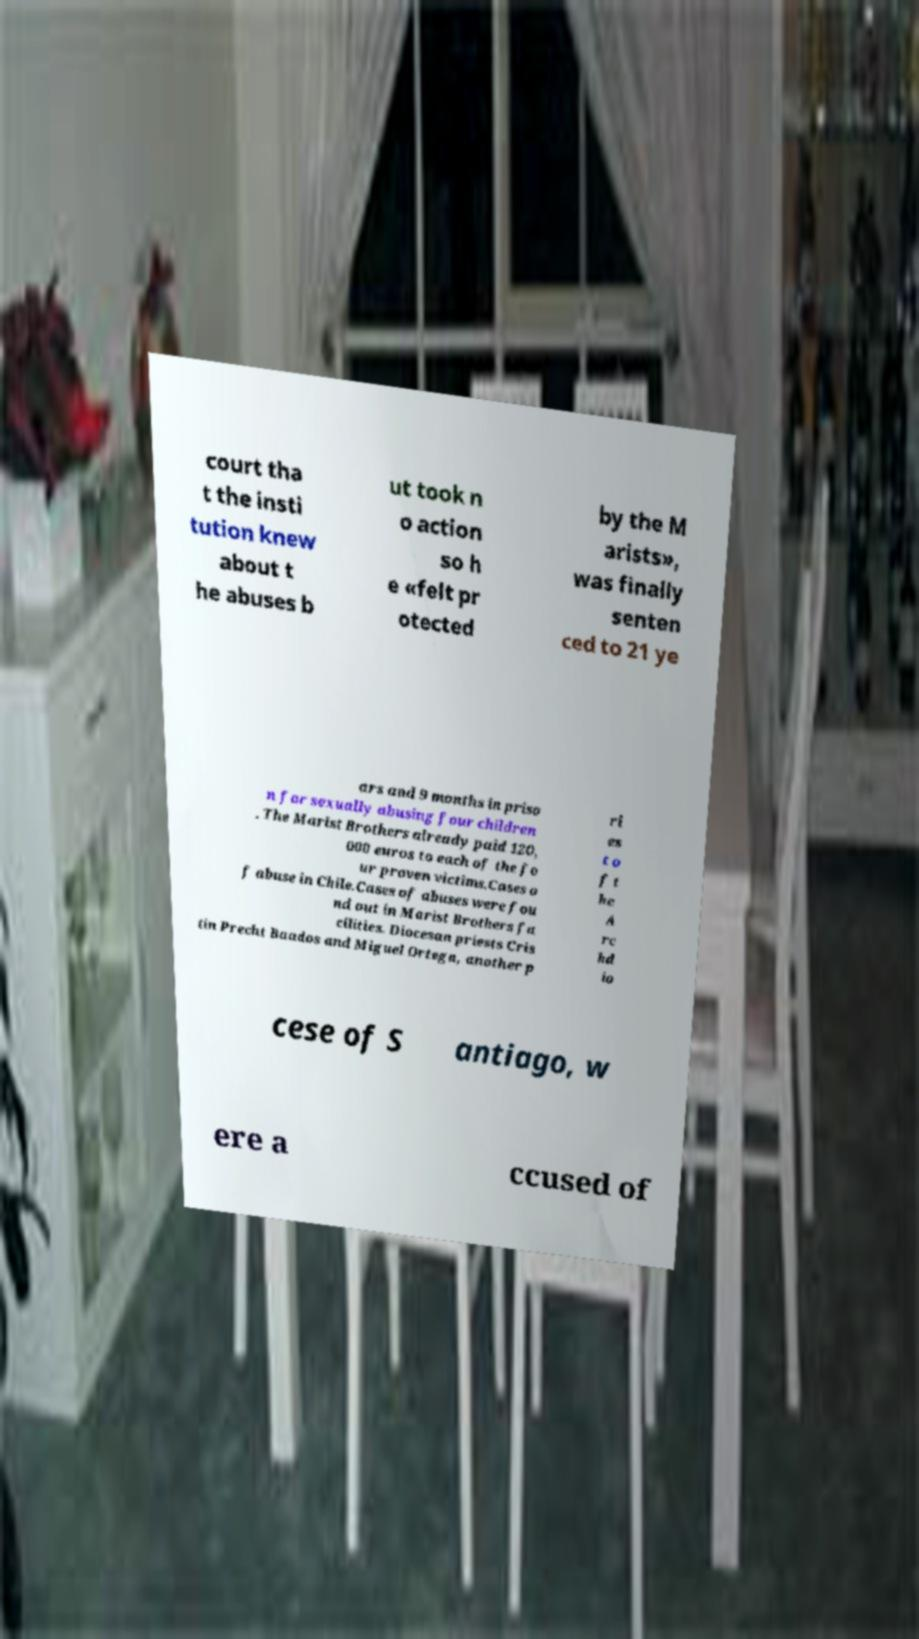I need the written content from this picture converted into text. Can you do that? court tha t the insti tution knew about t he abuses b ut took n o action so h e «felt pr otected by the M arists», was finally senten ced to 21 ye ars and 9 months in priso n for sexually abusing four children . The Marist Brothers already paid 120, 000 euros to each of the fo ur proven victims.Cases o f abuse in Chile.Cases of abuses were fou nd out in Marist Brothers fa cilities. Diocesan priests Cris tin Precht Baados and Miguel Ortega, another p ri es t o f t he A rc hd io cese of S antiago, w ere a ccused of 